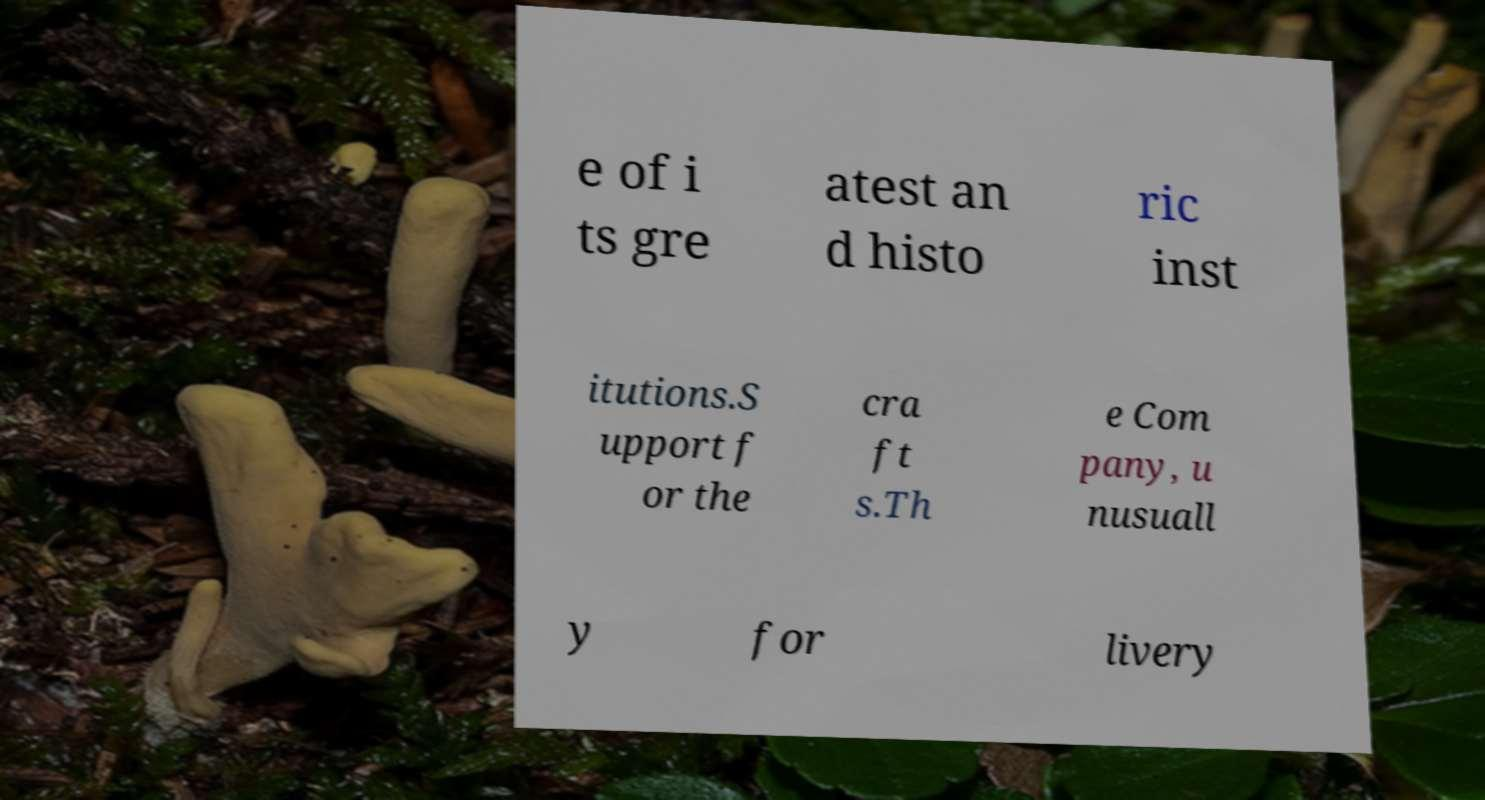I need the written content from this picture converted into text. Can you do that? e of i ts gre atest an d histo ric inst itutions.S upport f or the cra ft s.Th e Com pany, u nusuall y for livery 